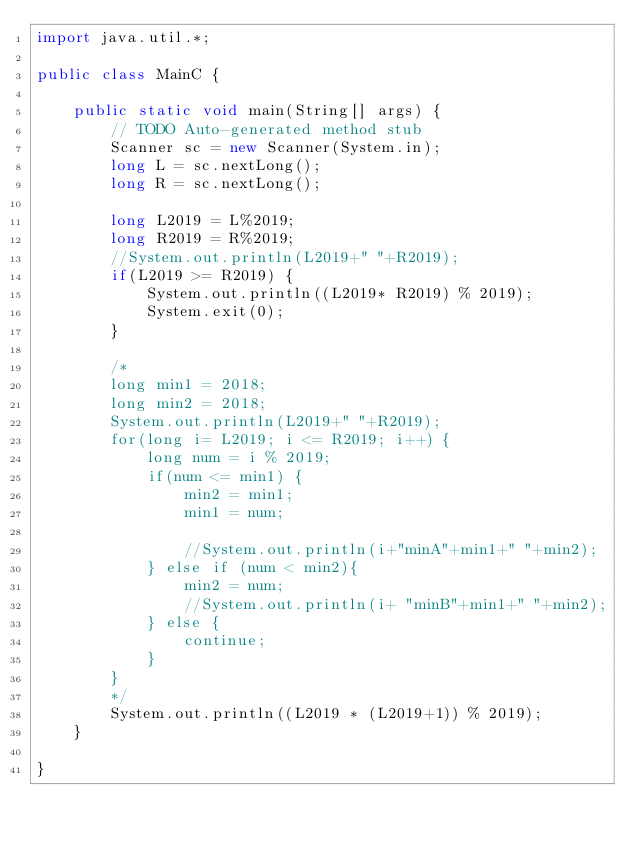<code> <loc_0><loc_0><loc_500><loc_500><_Java_>import java.util.*;

public class MainC {

	public static void main(String[] args) {
		// TODO Auto-generated method stub
		Scanner sc = new Scanner(System.in);
		long L = sc.nextLong();
		long R = sc.nextLong();
		
		long L2019 = L%2019;
		long R2019 = R%2019;
		//System.out.println(L2019+" "+R2019);
		if(L2019 >= R2019) {
			System.out.println((L2019* R2019) % 2019);
			System.exit(0);
		}
		
		/*
		long min1 = 2018;
		long min2 = 2018;
		System.out.println(L2019+" "+R2019);
		for(long i= L2019; i <= R2019; i++) {
			long num = i % 2019;
			if(num <= min1) {
				min2 = min1;
				min1 = num;
				
				//System.out.println(i+"minA"+min1+" "+min2);
			} else if (num < min2){
				min2 = num;
				//System.out.println(i+ "minB"+min1+" "+min2);
			} else {
				continue;
			}
		}
		*/
		System.out.println((L2019 * (L2019+1)) % 2019);
	}

}</code> 